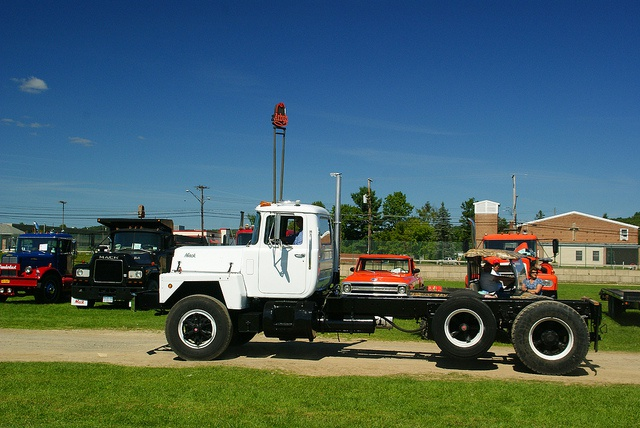Describe the objects in this image and their specific colors. I can see truck in navy, black, white, gray, and darkgray tones, truck in navy, black, gray, and darkgray tones, truck in navy, black, and maroon tones, truck in navy, black, red, and gray tones, and truck in navy, black, red, and gray tones in this image. 